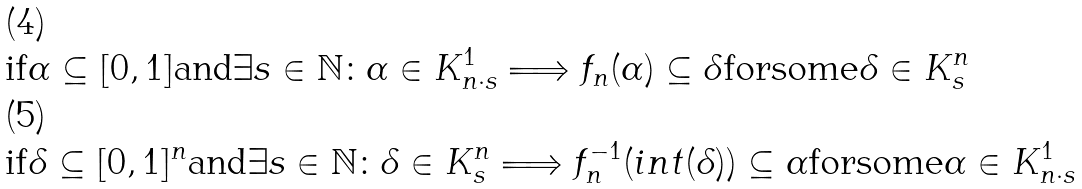<formula> <loc_0><loc_0><loc_500><loc_500>& \text {if} \alpha \subseteq [ 0 , 1 ] \text {and} \exists s \in \mathbb { N } \colon \alpha \in K ^ { 1 } _ { n \cdot s } \Longrightarrow f _ { n } ( \alpha ) \subseteq \delta \text {forsome} \delta \in K ^ { n } _ { s } \\ & \text {if} \delta \subseteq [ 0 , 1 ] ^ { n } \text {and} \exists s \in \mathbb { N } \colon \delta \in K ^ { n } _ { s } \Longrightarrow f _ { n } ^ { - 1 } ( i n t ( \delta ) ) \subseteq \alpha \text {forsome} \alpha \in K ^ { 1 } _ { n \cdot s }</formula> 